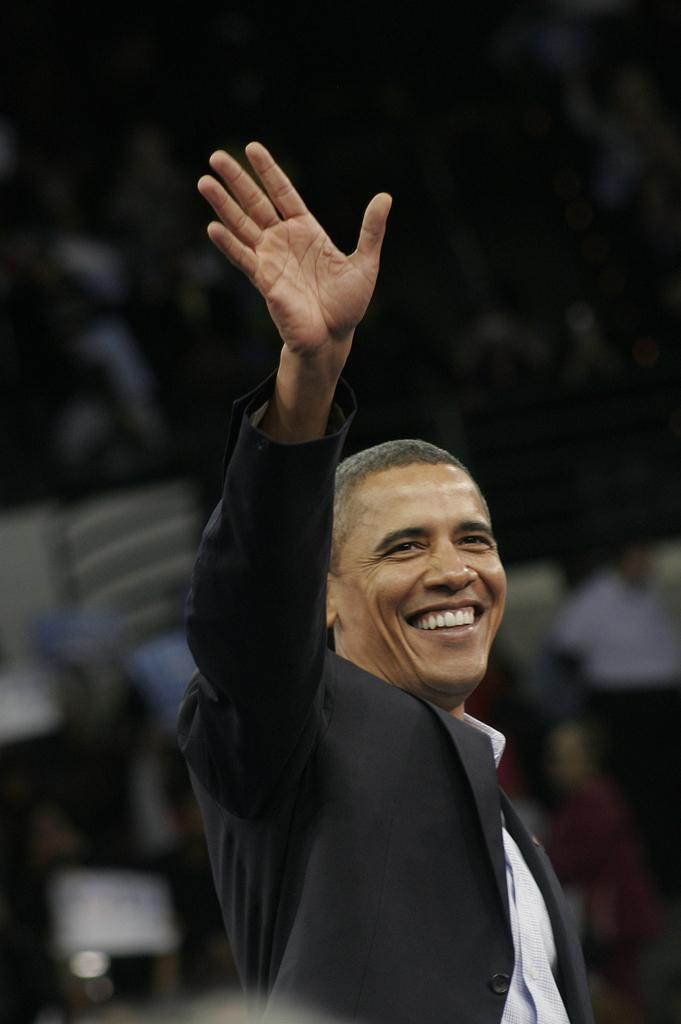What is the main subject of the image? There is a person standing in the center of the image. What is the person's facial expression in the image? The person is smiling. Can you describe the background of the image? The background of the image is blurred. What type of sock is the person wearing in the image? There is no sock visible in the image, as the person's feet are not shown. What selection of cacti can be seen in the background of the image? There are no cacti present in the image; the background is blurred. 